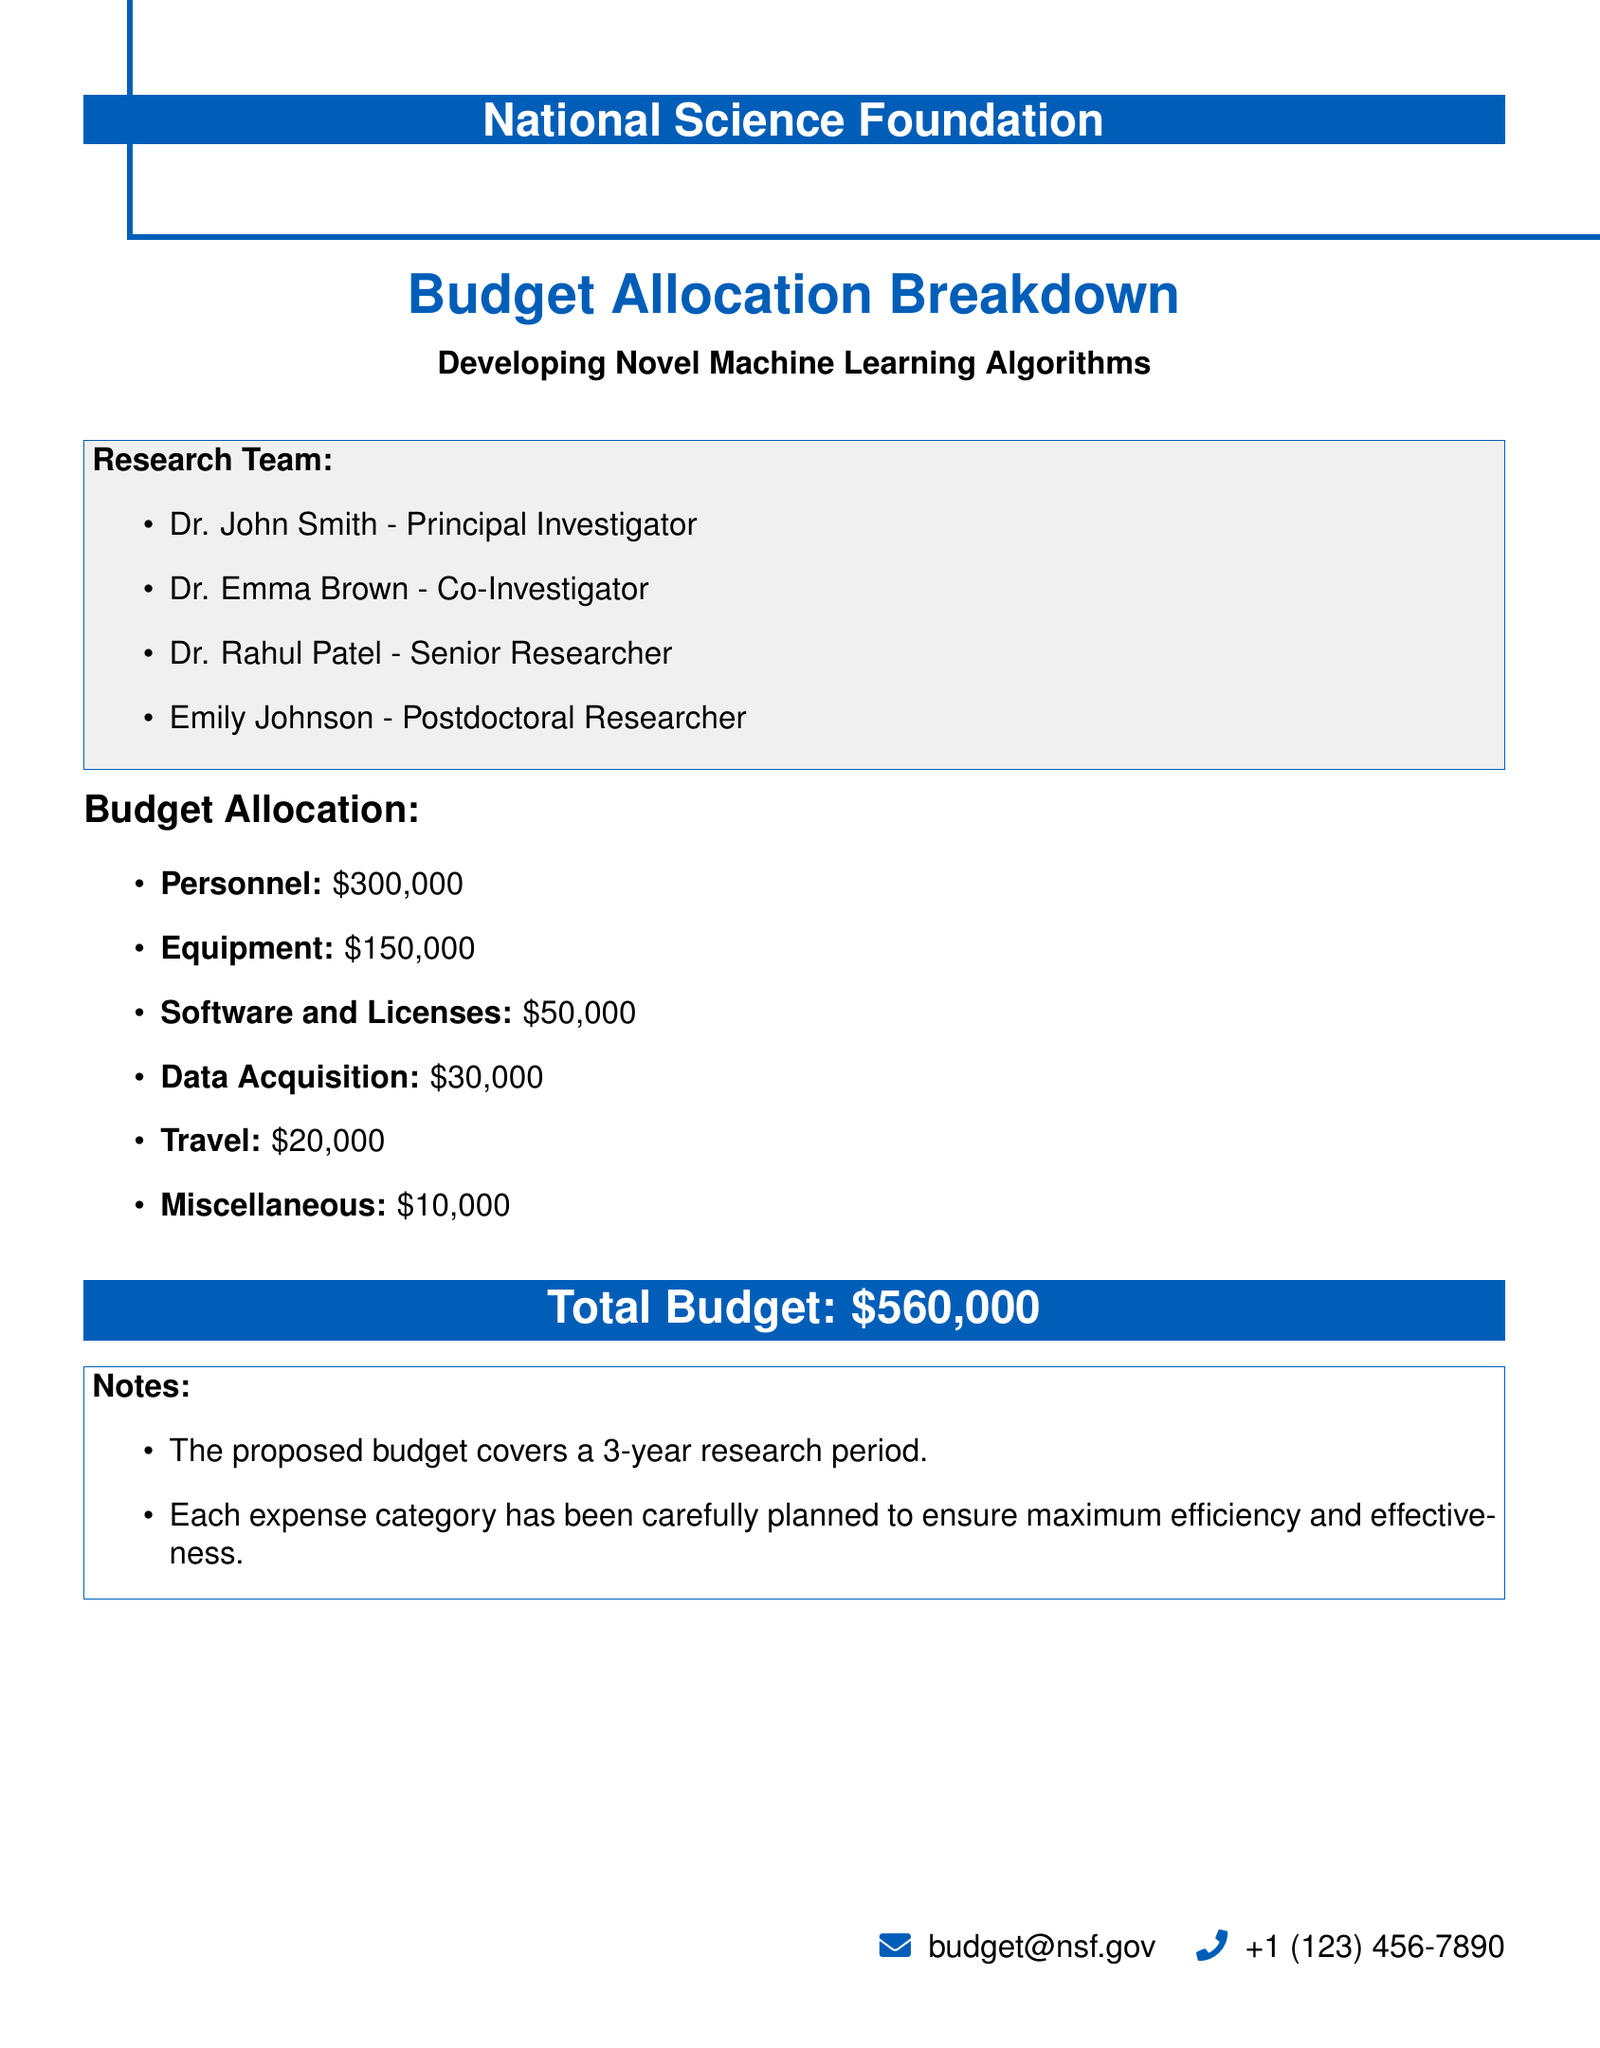What is the total budget? The total budget is explicitly stated in the document under the budget allocation section.
Answer: $560,000 Who is the Principal Investigator? The document lists the members of the research team including their roles; the Principal Investigator is identified as Dr. John Smith.
Answer: Dr. John Smith How much is allocated for personnel? The budget allocation section explicitly specifies the amount allocated for personnel.
Answer: $300,000 What is the equipment budget? The budget breakdown includes a specific amount designated for equipment, which can be found in the list.
Answer: $150,000 How many years does the proposed budget cover? There is a note in the document that mentions the duration for which the proposed budget is planned.
Answer: 3 years What is included in the miscellaneous budget? The budget breakdown includes a specific category labeled as miscellaneous, which has its own designated amount.
Answer: $10,000 Who are the Co-Investigator and Senior Researcher? The document lists the members of the research team along with their roles, which includes the Co-Investigator and Senior Researcher.
Answer: Dr. Emma Brown, Dr. Rahul Patel How much funds are allocated for travel? The total amount allocated for travel is given in the budget allocation section of the document.
Answer: $20,000 What category has the lowest budget allocation? By inspecting the provided budget allocation breakdown, the category with the lowest allocation is identified.
Answer: Miscellaneous 